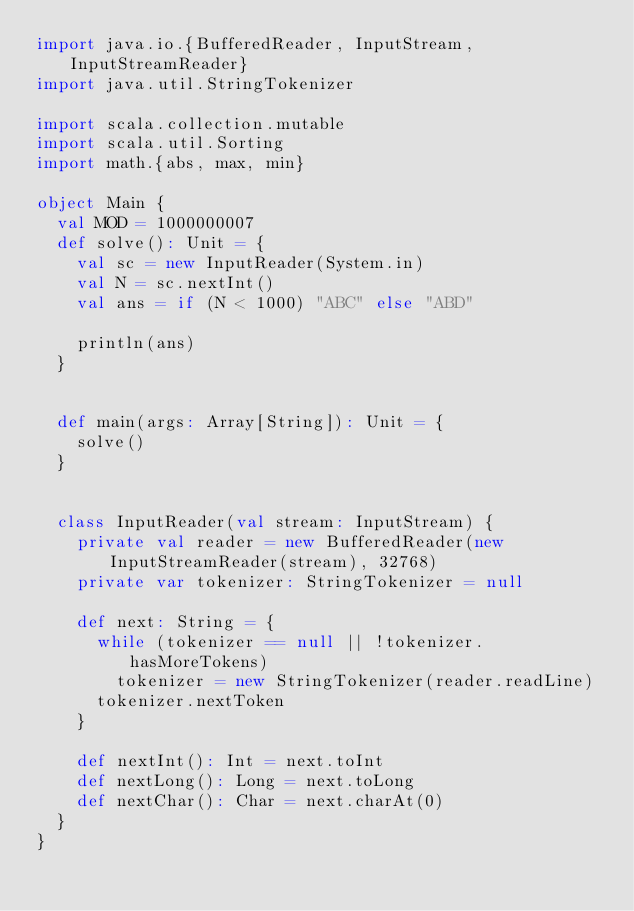Convert code to text. <code><loc_0><loc_0><loc_500><loc_500><_Scala_>import java.io.{BufferedReader, InputStream, InputStreamReader}
import java.util.StringTokenizer

import scala.collection.mutable
import scala.util.Sorting
import math.{abs, max, min}

object Main {
  val MOD = 1000000007
  def solve(): Unit = {
    val sc = new InputReader(System.in)
    val N = sc.nextInt()
    val ans = if (N < 1000) "ABC" else "ABD"

    println(ans)
  }


  def main(args: Array[String]): Unit = {
    solve()
  }


  class InputReader(val stream: InputStream) {
    private val reader = new BufferedReader(new InputStreamReader(stream), 32768)
    private var tokenizer: StringTokenizer = null

    def next: String = {
      while (tokenizer == null || !tokenizer.hasMoreTokens)
        tokenizer = new StringTokenizer(reader.readLine)
      tokenizer.nextToken
    }

    def nextInt(): Int = next.toInt
    def nextLong(): Long = next.toLong
    def nextChar(): Char = next.charAt(0)
  }
}
</code> 